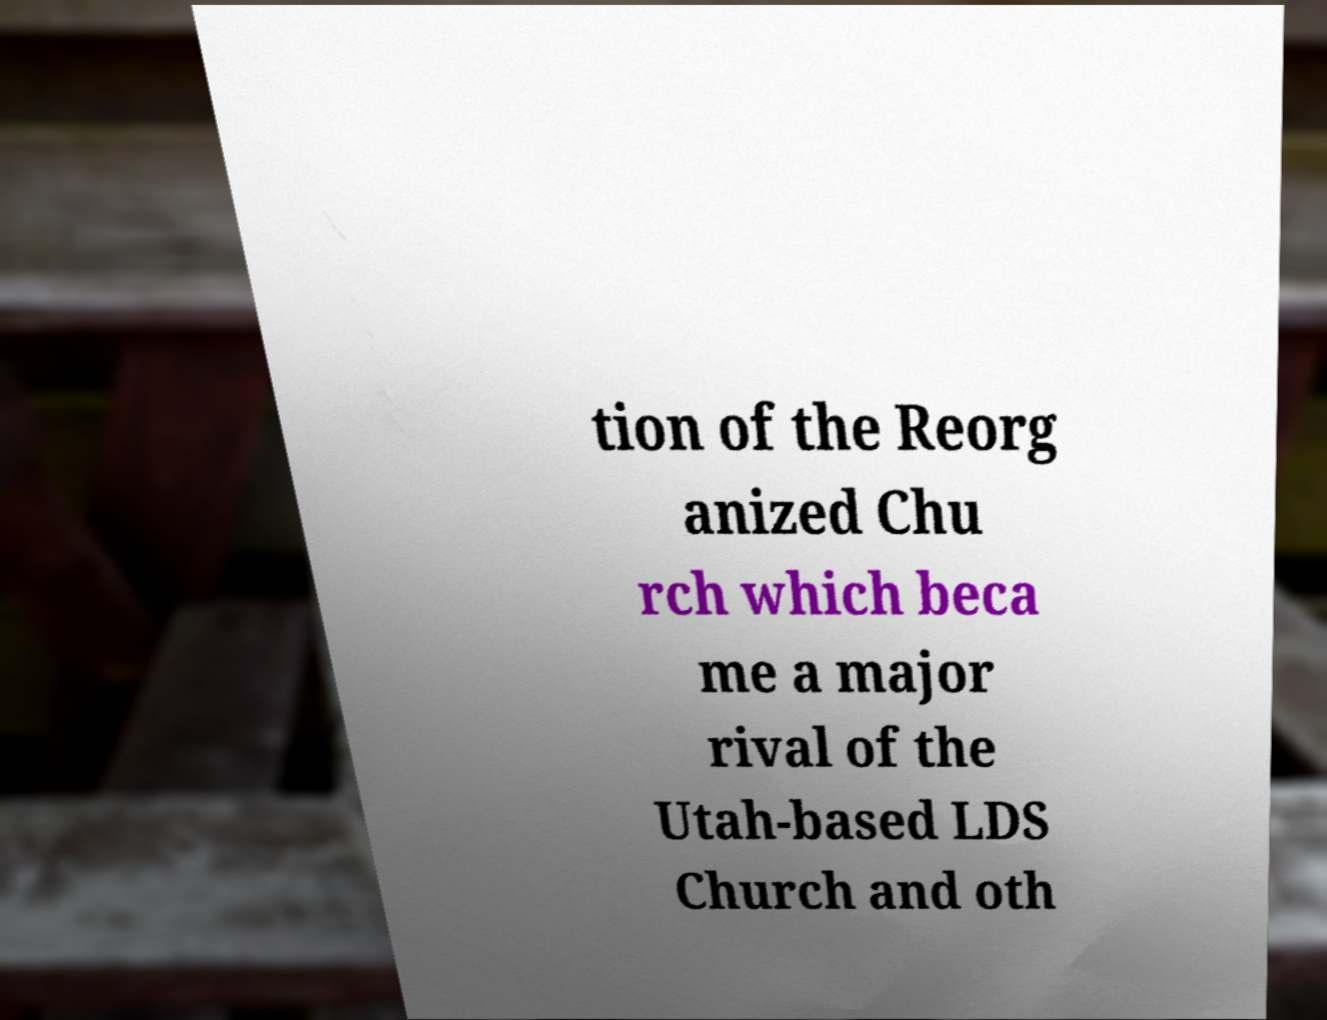Can you read and provide the text displayed in the image?This photo seems to have some interesting text. Can you extract and type it out for me? tion of the Reorg anized Chu rch which beca me a major rival of the Utah-based LDS Church and oth 